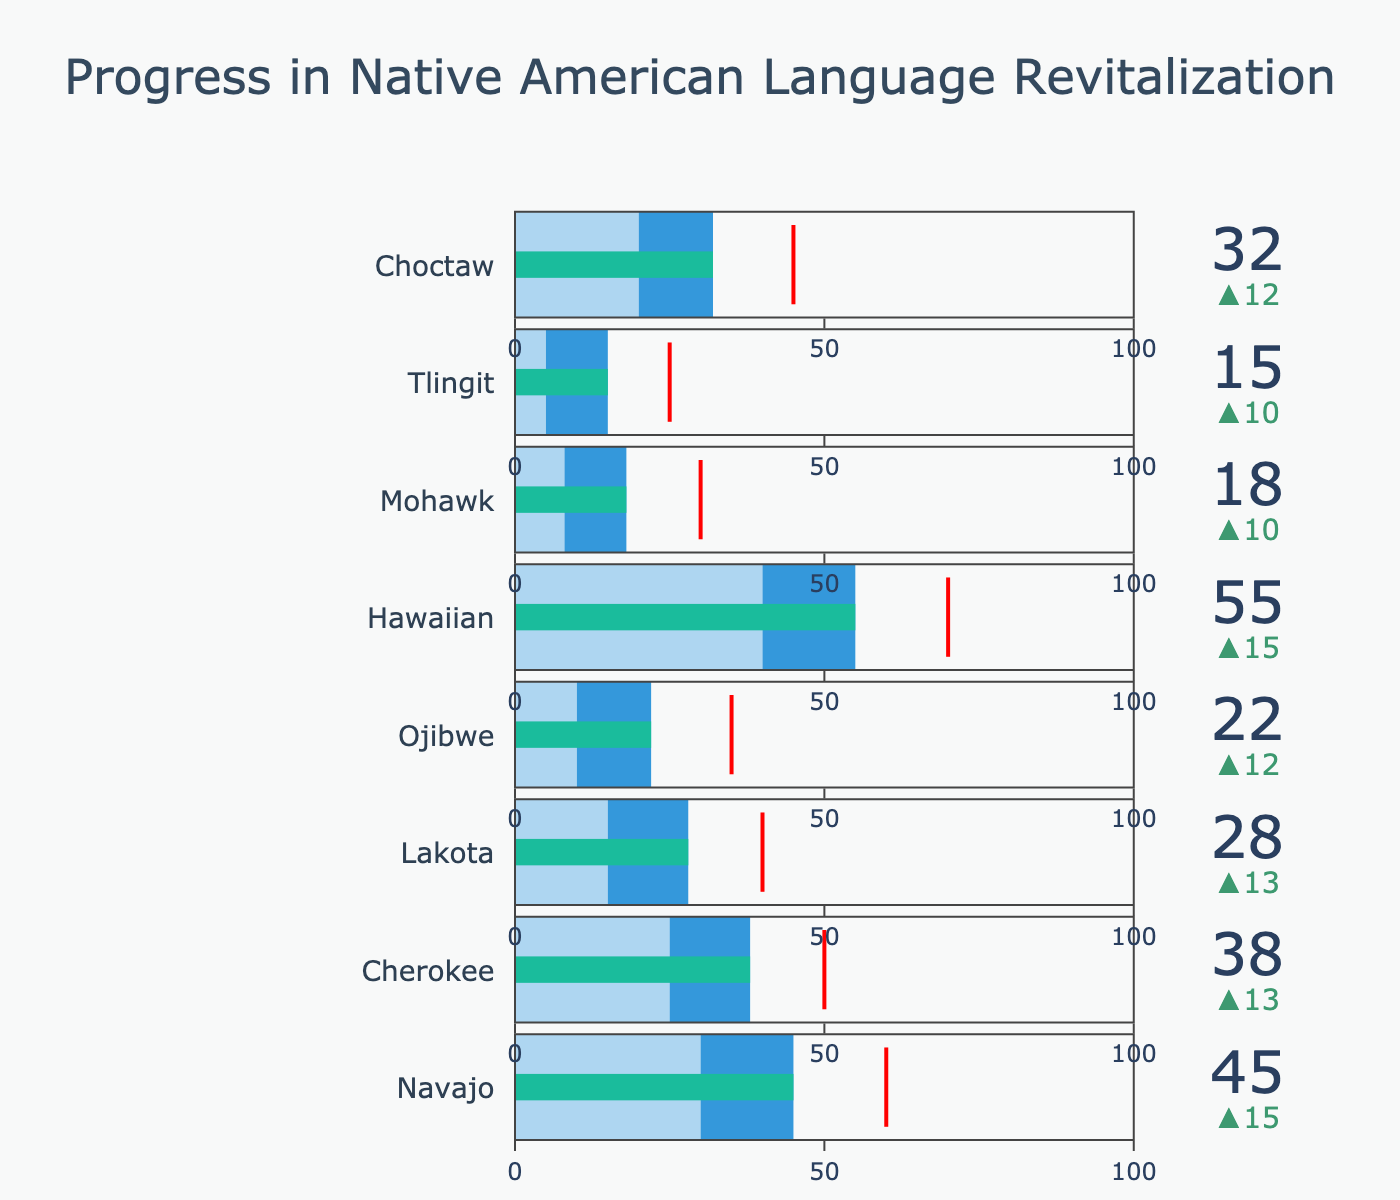What language has the highest actual progress in percentage? The language with the highest actual progress is the one with the largest value in the "Actual Progress (%)" section of the bullet chart.
Answer: Hawaiian What is the historical benchmark for the Lakota language? Look at the section of the chart for the Lakota language and identify the historical benchmark value from the displayed data.
Answer: 15% Which language has the smallest difference between actual progress and its target? Calculate the difference between the "Actual Progress (%)" and "Target (%)" for each language and find the smallest value.
Answer: Cherokee How much higher is the actual progress for the Navajo language compared to its historical benchmark? Subtract the historical benchmark of the Navajo language from its actual progress. (45% - 30%)
Answer: 15% Is the actual progress for the Hawaiian language above or below its target? Compare the actual progress of the Hawaiian language to its target value shown in the bullet chart.
Answer: Below Which language has the lowest historical benchmark? Look at all the historical benchmark values and identify the smallest one.
Answer: Tlingit Compare the actual progress of the Navajo and Cherokee languages. Which one is higher? Compare the actual progress percentage of the Navajo language to that of the Cherokee language.
Answer: Navajo What is the average target percentage for all the languages shown? Sum the target percentages for all the languages and divide by the number of languages. (60 + 50 + 40 + 35 + 70 + 30 + 25 + 45) / 8
Answer: 44.375% What progress percentage is shown as the threshold (red line) for the Mohawk language? Identify the progress percentage indicated by the red line for the Mohawk language.
Answer: 30% Which language is closest to meeting its target percentage based on actual progress? Determine the absolute difference between the actual progress and the target percentage for each language and identify the smallest one.
Answer: Hawaiian 